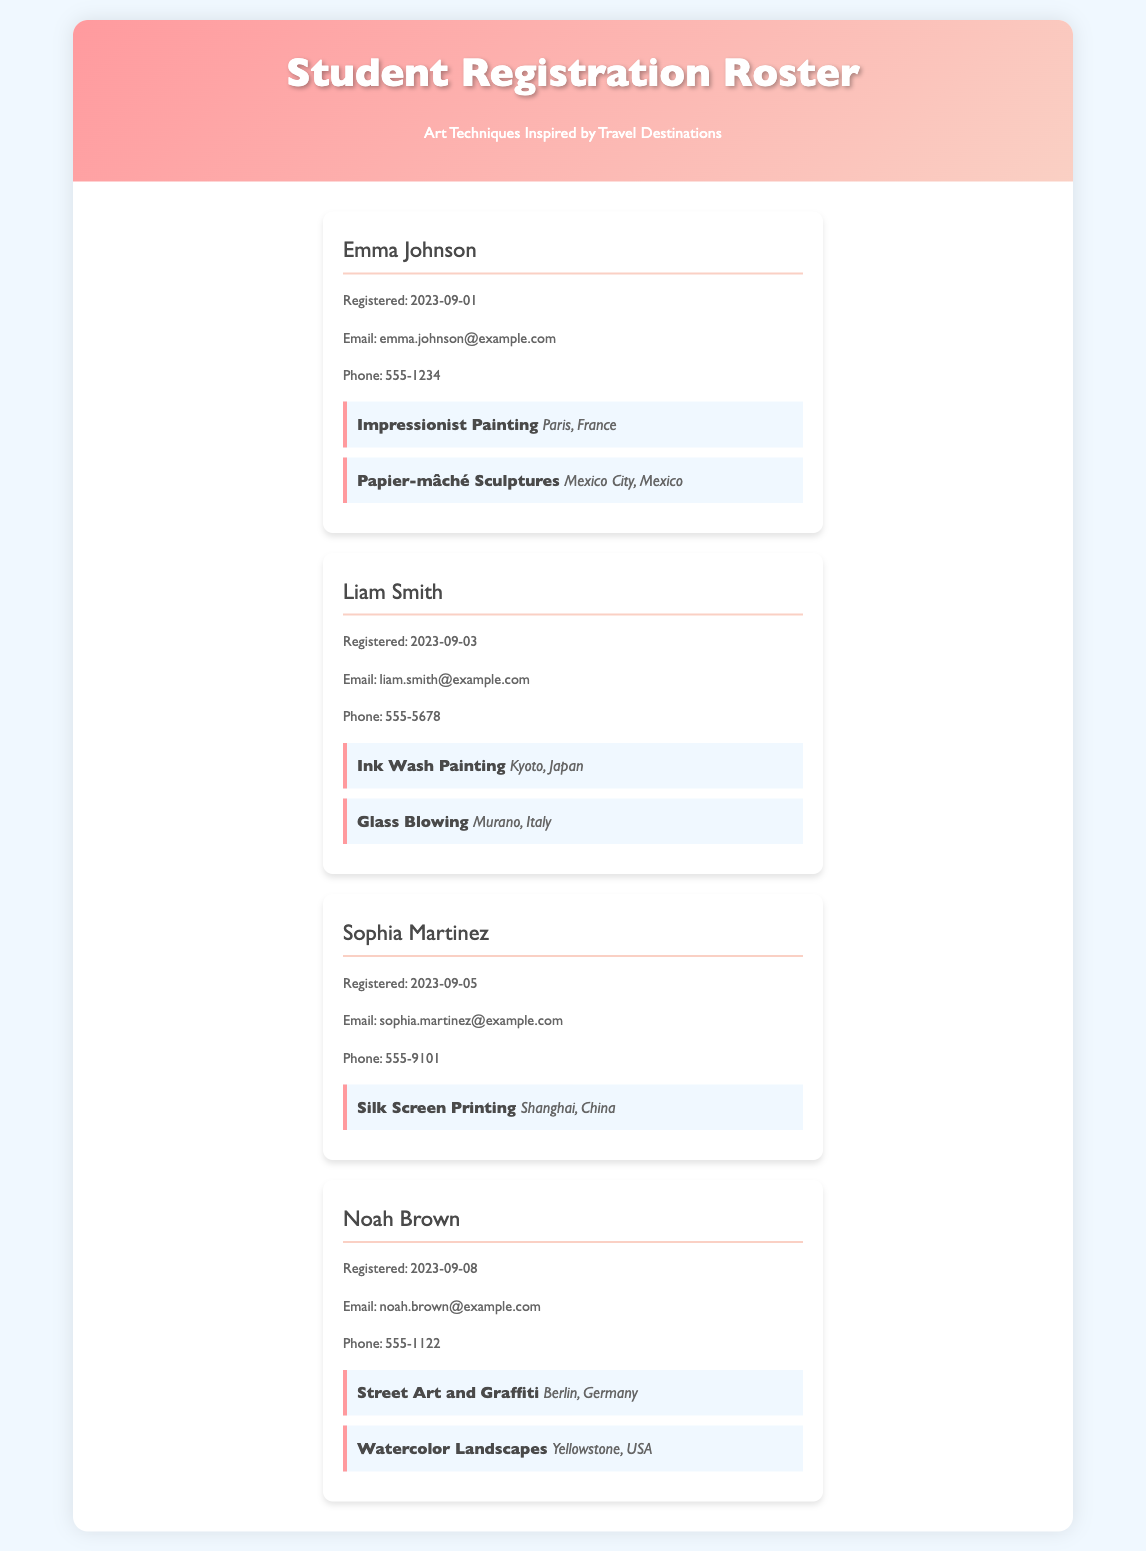what is the name of the first student? The first student listed is Emma Johnson.
Answer: Emma Johnson when did Liam Smith register? Liam Smith's registration date is mentioned in the document.
Answer: 2023-09-03 which class is Sophia Martinez attending? The document specifies the classes attended by Sophia Martinez.
Answer: Silk Screen Printing what is Noah Brown's email address? Email addresses are provided for each student in the document.
Answer: noah.brown@example.com how many classes is Emma Johnson taking? The document lists the classes for each student. Emma Johnson has two classes.
Answer: 2 which destination is associated with Ink Wash Painting? The class destination is mentioned alongside the art technique for each student.
Answer: Kyoto, Japan what is the contact number of the last student? The contact numbers are provided in the student information section.
Answer: 555-1122 who is taking classes inspired by Berlin, Germany? The document specifies Noah Brown is taking classes related to Berlin.
Answer: Noah Brown what technique is taught in the class associated with Shanghai, China? The document specifically mentions the technique associated with each class.
Answer: Silk Screen Printing 